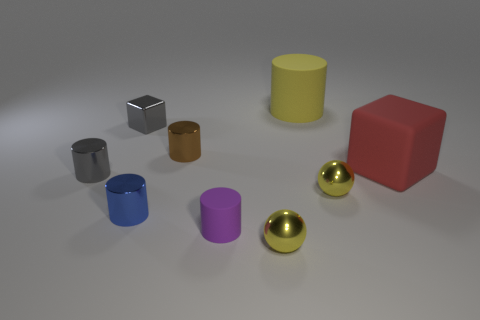Subtract all yellow balls. How many were subtracted if there are1yellow balls left? 1 Subtract 2 cylinders. How many cylinders are left? 3 Subtract all blue cylinders. How many cylinders are left? 4 Subtract all purple cylinders. How many cylinders are left? 4 Subtract all green cylinders. Subtract all purple spheres. How many cylinders are left? 5 Subtract all spheres. How many objects are left? 7 Add 1 tiny brown rubber spheres. How many objects exist? 10 Add 3 tiny green things. How many tiny green things exist? 3 Subtract 0 green cubes. How many objects are left? 9 Subtract all small blue things. Subtract all large yellow cylinders. How many objects are left? 7 